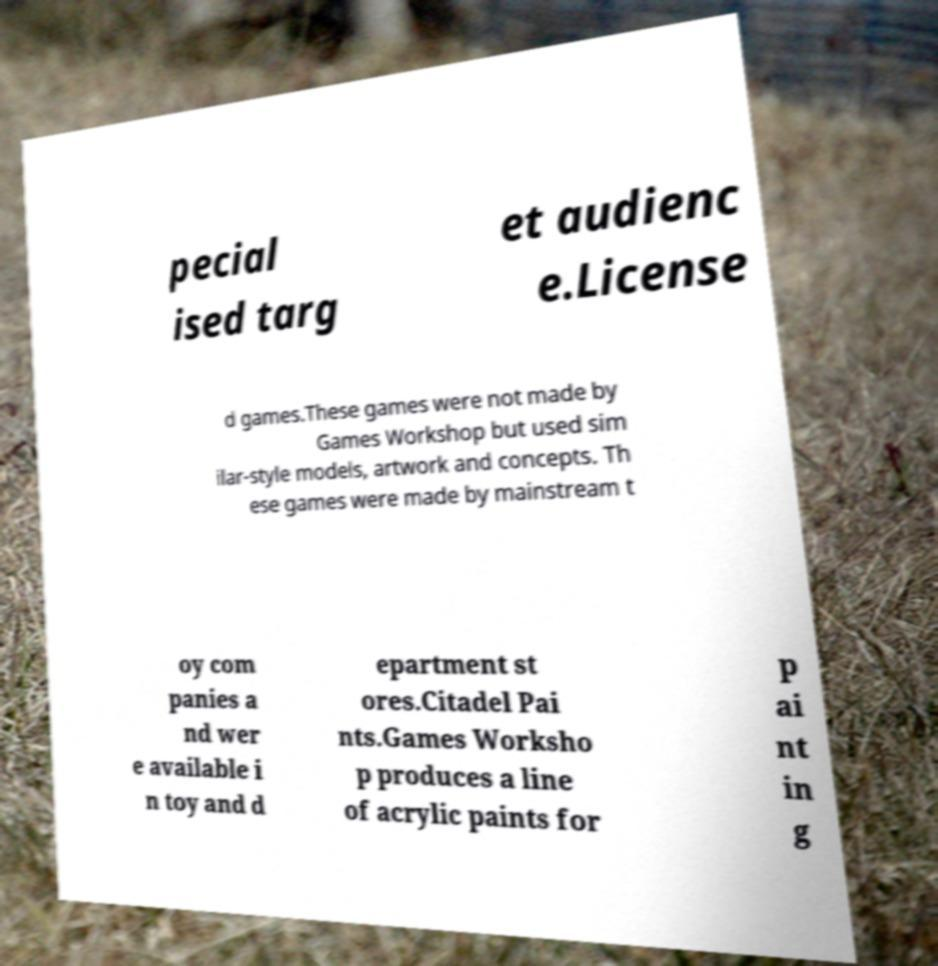Please read and relay the text visible in this image. What does it say? pecial ised targ et audienc e.License d games.These games were not made by Games Workshop but used sim ilar-style models, artwork and concepts. Th ese games were made by mainstream t oy com panies a nd wer e available i n toy and d epartment st ores.Citadel Pai nts.Games Worksho p produces a line of acrylic paints for p ai nt in g 